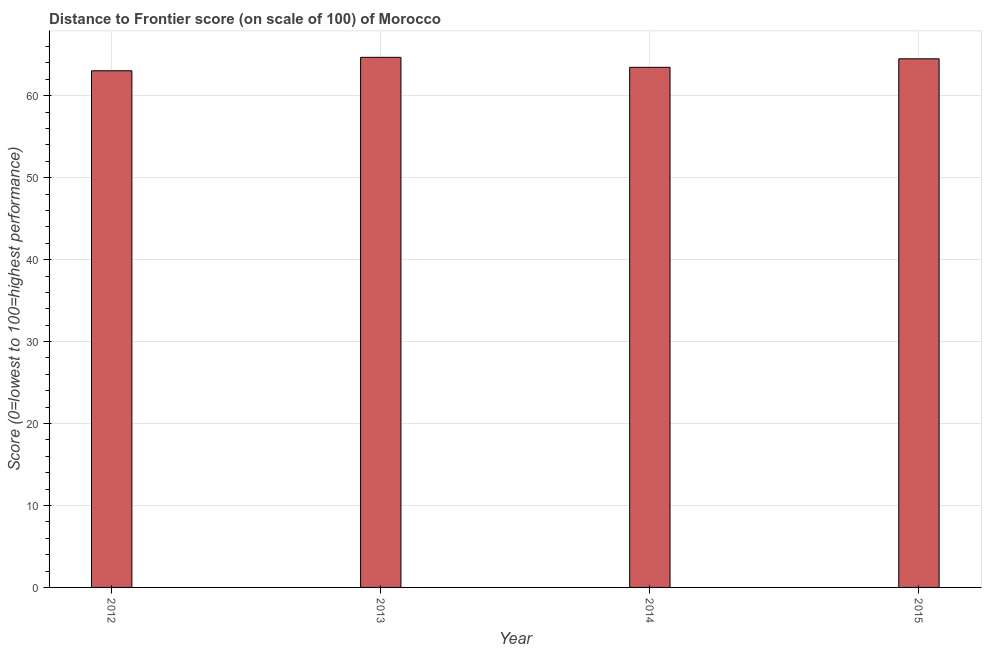Does the graph contain any zero values?
Provide a short and direct response. No. Does the graph contain grids?
Keep it short and to the point. Yes. What is the title of the graph?
Provide a short and direct response. Distance to Frontier score (on scale of 100) of Morocco. What is the label or title of the Y-axis?
Keep it short and to the point. Score (0=lowest to 100=highest performance). What is the distance to frontier score in 2012?
Your answer should be very brief. 63.05. Across all years, what is the maximum distance to frontier score?
Keep it short and to the point. 64.69. Across all years, what is the minimum distance to frontier score?
Ensure brevity in your answer.  63.05. In which year was the distance to frontier score minimum?
Your answer should be very brief. 2012. What is the sum of the distance to frontier score?
Your response must be concise. 255.72. What is the difference between the distance to frontier score in 2012 and 2014?
Your answer should be very brief. -0.42. What is the average distance to frontier score per year?
Make the answer very short. 63.93. What is the median distance to frontier score?
Provide a short and direct response. 63.99. Is the distance to frontier score in 2013 less than that in 2014?
Your answer should be very brief. No. Is the difference between the distance to frontier score in 2013 and 2014 greater than the difference between any two years?
Offer a terse response. No. What is the difference between the highest and the second highest distance to frontier score?
Make the answer very short. 0.18. Is the sum of the distance to frontier score in 2012 and 2013 greater than the maximum distance to frontier score across all years?
Make the answer very short. Yes. What is the difference between the highest and the lowest distance to frontier score?
Keep it short and to the point. 1.64. In how many years, is the distance to frontier score greater than the average distance to frontier score taken over all years?
Your answer should be compact. 2. How many years are there in the graph?
Your answer should be compact. 4. What is the Score (0=lowest to 100=highest performance) of 2012?
Your response must be concise. 63.05. What is the Score (0=lowest to 100=highest performance) in 2013?
Your response must be concise. 64.69. What is the Score (0=lowest to 100=highest performance) in 2014?
Offer a terse response. 63.47. What is the Score (0=lowest to 100=highest performance) of 2015?
Provide a succinct answer. 64.51. What is the difference between the Score (0=lowest to 100=highest performance) in 2012 and 2013?
Offer a terse response. -1.64. What is the difference between the Score (0=lowest to 100=highest performance) in 2012 and 2014?
Offer a terse response. -0.42. What is the difference between the Score (0=lowest to 100=highest performance) in 2012 and 2015?
Provide a succinct answer. -1.46. What is the difference between the Score (0=lowest to 100=highest performance) in 2013 and 2014?
Ensure brevity in your answer.  1.22. What is the difference between the Score (0=lowest to 100=highest performance) in 2013 and 2015?
Your response must be concise. 0.18. What is the difference between the Score (0=lowest to 100=highest performance) in 2014 and 2015?
Provide a short and direct response. -1.04. What is the ratio of the Score (0=lowest to 100=highest performance) in 2012 to that in 2013?
Ensure brevity in your answer.  0.97. What is the ratio of the Score (0=lowest to 100=highest performance) in 2012 to that in 2014?
Provide a short and direct response. 0.99. What is the ratio of the Score (0=lowest to 100=highest performance) in 2012 to that in 2015?
Your answer should be very brief. 0.98. What is the ratio of the Score (0=lowest to 100=highest performance) in 2013 to that in 2014?
Provide a succinct answer. 1.02. 